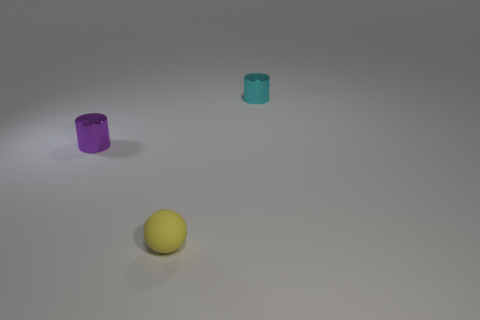Subtract all brown cylinders. Subtract all yellow balls. How many cylinders are left? 2 Add 3 small red matte cubes. How many objects exist? 6 Subtract all cylinders. How many objects are left? 1 Subtract all brown rubber things. Subtract all yellow things. How many objects are left? 2 Add 2 cylinders. How many cylinders are left? 4 Add 3 tiny matte balls. How many tiny matte balls exist? 4 Subtract 0 gray spheres. How many objects are left? 3 